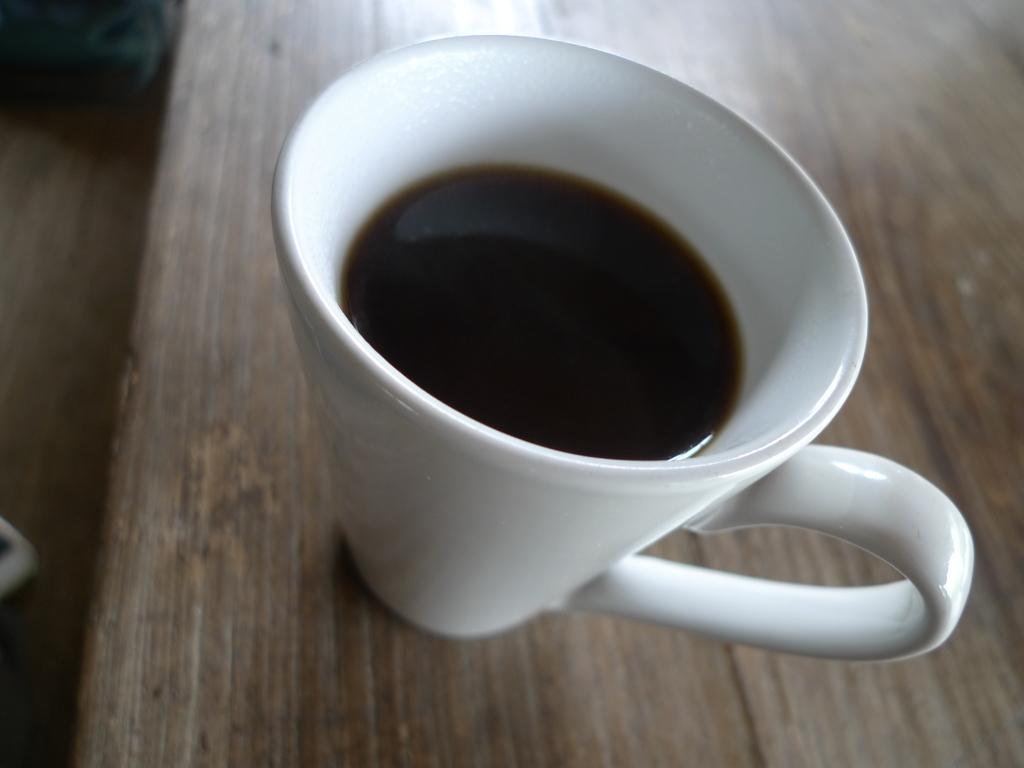Please provide a concise description of this image. In the center of this picture we can see a white color coffee mug containing a liquid which is placed on the top of the wooden table. On the left we can see some objects. 